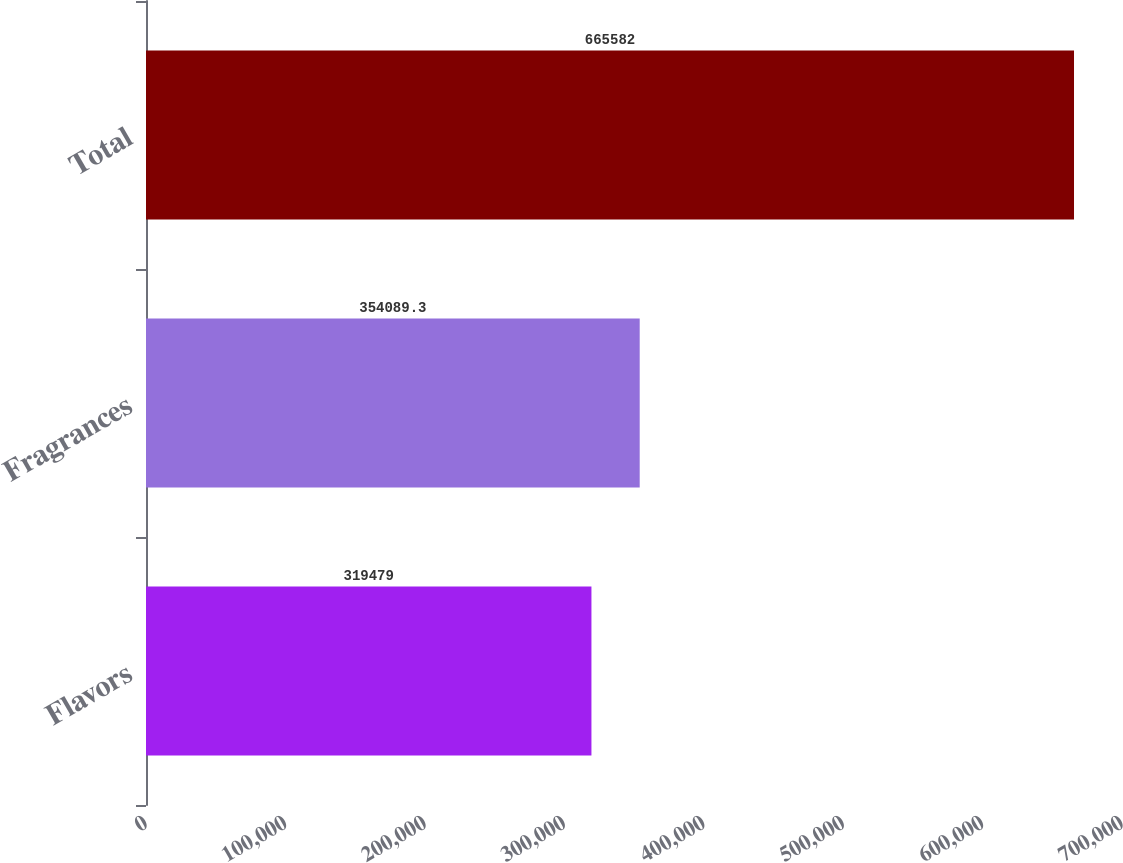Convert chart. <chart><loc_0><loc_0><loc_500><loc_500><bar_chart><fcel>Flavors<fcel>Fragrances<fcel>Total<nl><fcel>319479<fcel>354089<fcel>665582<nl></chart> 